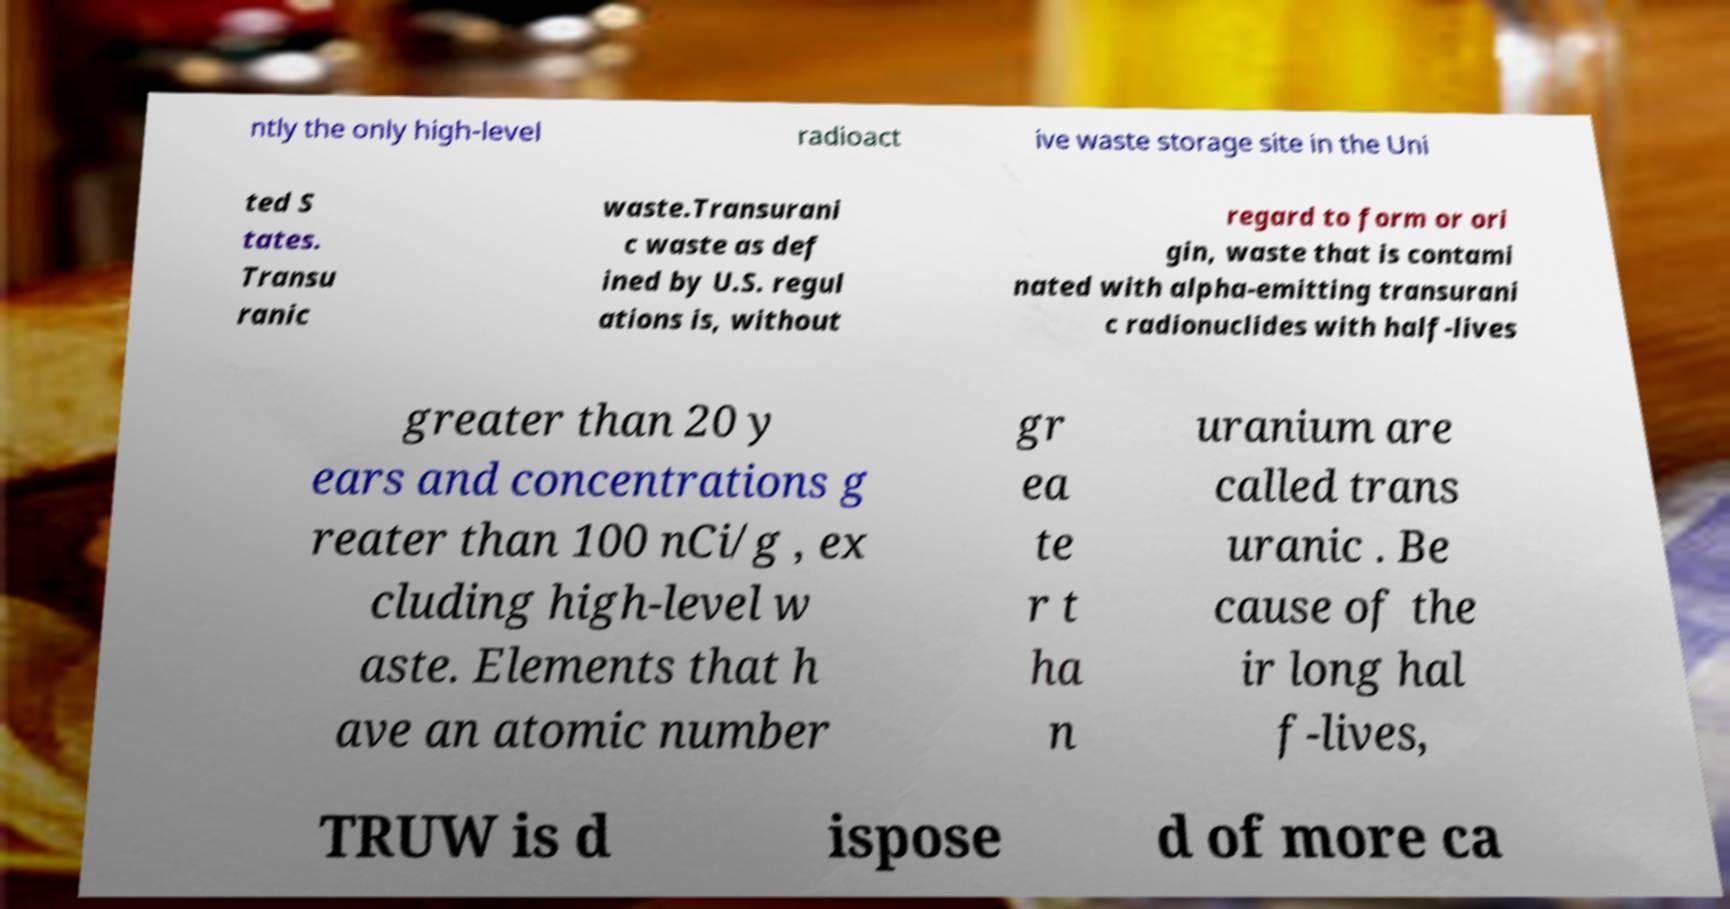Please identify and transcribe the text found in this image. ntly the only high-level radioact ive waste storage site in the Uni ted S tates. Transu ranic waste.Transurani c waste as def ined by U.S. regul ations is, without regard to form or ori gin, waste that is contami nated with alpha-emitting transurani c radionuclides with half-lives greater than 20 y ears and concentrations g reater than 100 nCi/g , ex cluding high-level w aste. Elements that h ave an atomic number gr ea te r t ha n uranium are called trans uranic . Be cause of the ir long hal f-lives, TRUW is d ispose d of more ca 